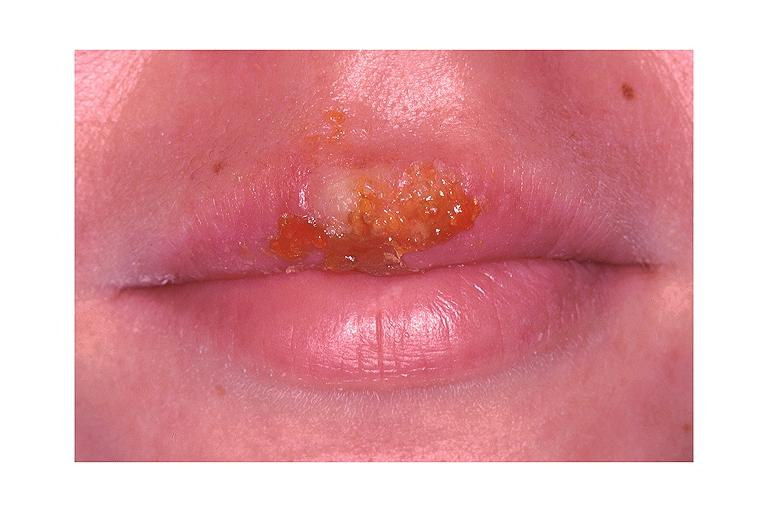what is present?
Answer the question using a single word or phrase. Oral 